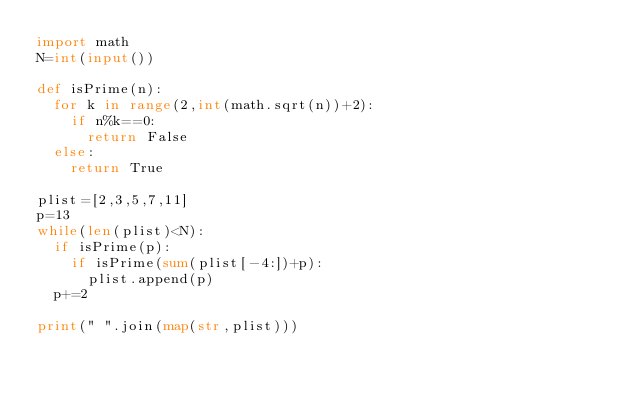<code> <loc_0><loc_0><loc_500><loc_500><_Python_>import math
N=int(input())

def isPrime(n):
  for k in range(2,int(math.sqrt(n))+2):
    if n%k==0:
      return False
  else:
    return True

plist=[2,3,5,7,11]
p=13
while(len(plist)<N):
  if isPrime(p):
    if isPrime(sum(plist[-4:])+p):
      plist.append(p)
  p+=2
    
print(" ".join(map(str,plist)))</code> 